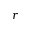Convert formula to latex. <formula><loc_0><loc_0><loc_500><loc_500>r</formula> 